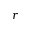Convert formula to latex. <formula><loc_0><loc_0><loc_500><loc_500>r</formula> 